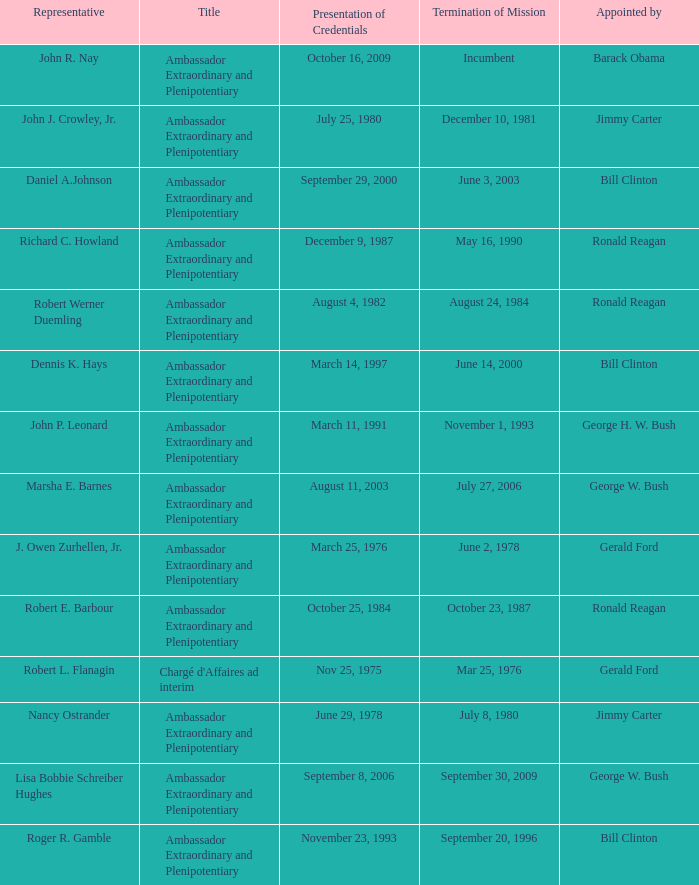Write the full table. {'header': ['Representative', 'Title', 'Presentation of Credentials', 'Termination of Mission', 'Appointed by'], 'rows': [['John R. Nay', 'Ambassador Extraordinary and Plenipotentiary', 'October 16, 2009', 'Incumbent', 'Barack Obama'], ['John J. Crowley, Jr.', 'Ambassador Extraordinary and Plenipotentiary', 'July 25, 1980', 'December 10, 1981', 'Jimmy Carter'], ['Daniel A.Johnson', 'Ambassador Extraordinary and Plenipotentiary', 'September 29, 2000', 'June 3, 2003', 'Bill Clinton'], ['Richard C. Howland', 'Ambassador Extraordinary and Plenipotentiary', 'December 9, 1987', 'May 16, 1990', 'Ronald Reagan'], ['Robert Werner Duemling', 'Ambassador Extraordinary and Plenipotentiary', 'August 4, 1982', 'August 24, 1984', 'Ronald Reagan'], ['Dennis K. Hays', 'Ambassador Extraordinary and Plenipotentiary', 'March 14, 1997', 'June 14, 2000', 'Bill Clinton'], ['John P. Leonard', 'Ambassador Extraordinary and Plenipotentiary', 'March 11, 1991', 'November 1, 1993', 'George H. W. Bush'], ['Marsha E. Barnes', 'Ambassador Extraordinary and Plenipotentiary', 'August 11, 2003', 'July 27, 2006', 'George W. Bush'], ['J. Owen Zurhellen, Jr.', 'Ambassador Extraordinary and Plenipotentiary', 'March 25, 1976', 'June 2, 1978', 'Gerald Ford'], ['Robert E. Barbour', 'Ambassador Extraordinary and Plenipotentiary', 'October 25, 1984', 'October 23, 1987', 'Ronald Reagan'], ['Robert L. Flanagin', "Chargé d'Affaires ad interim", 'Nov 25, 1975', 'Mar 25, 1976', 'Gerald Ford'], ['Nancy Ostrander', 'Ambassador Extraordinary and Plenipotentiary', 'June 29, 1978', 'July 8, 1980', 'Jimmy Carter'], ['Lisa Bobbie Schreiber Hughes', 'Ambassador Extraordinary and Plenipotentiary', 'September 8, 2006', 'September 30, 2009', 'George W. Bush'], ['Roger R. Gamble', 'Ambassador Extraordinary and Plenipotentiary', 'November 23, 1993', 'September 20, 1996', 'Bill Clinton']]} What is the Termination of Mission date for Marsha E. Barnes, the Ambassador Extraordinary and Plenipotentiary? July 27, 2006. 